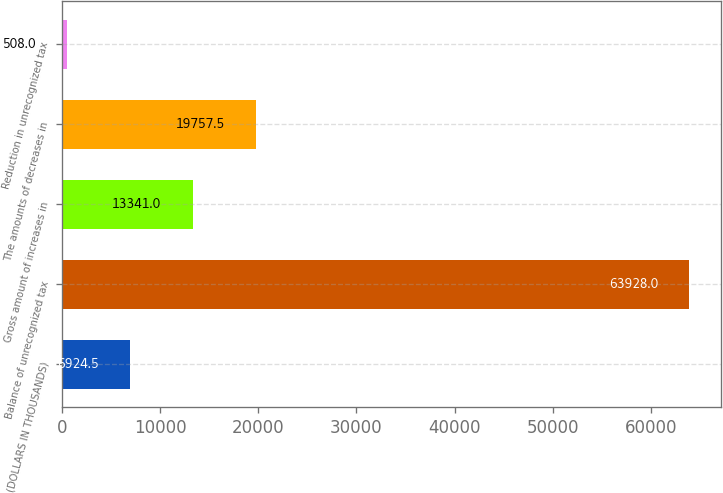Convert chart. <chart><loc_0><loc_0><loc_500><loc_500><bar_chart><fcel>(DOLLARS IN THOUSANDS)<fcel>Balance of unrecognized tax<fcel>Gross amount of increases in<fcel>The amounts of decreases in<fcel>Reduction in unrecognized tax<nl><fcel>6924.5<fcel>63928<fcel>13341<fcel>19757.5<fcel>508<nl></chart> 